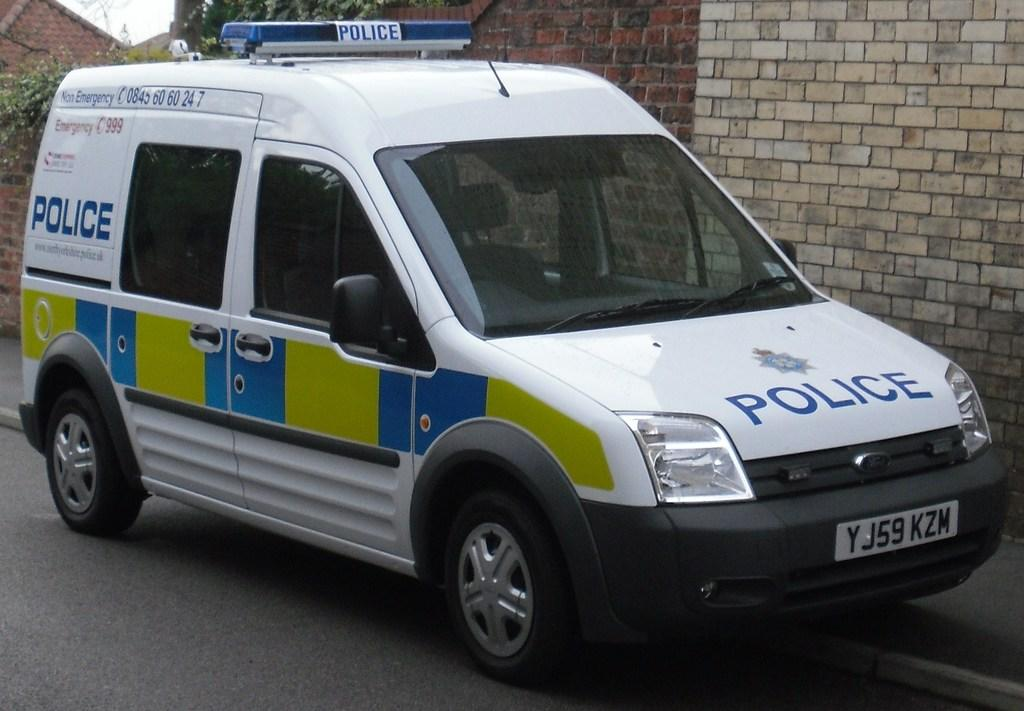<image>
Present a compact description of the photo's key features. White van which says POLICE on it in blue. 